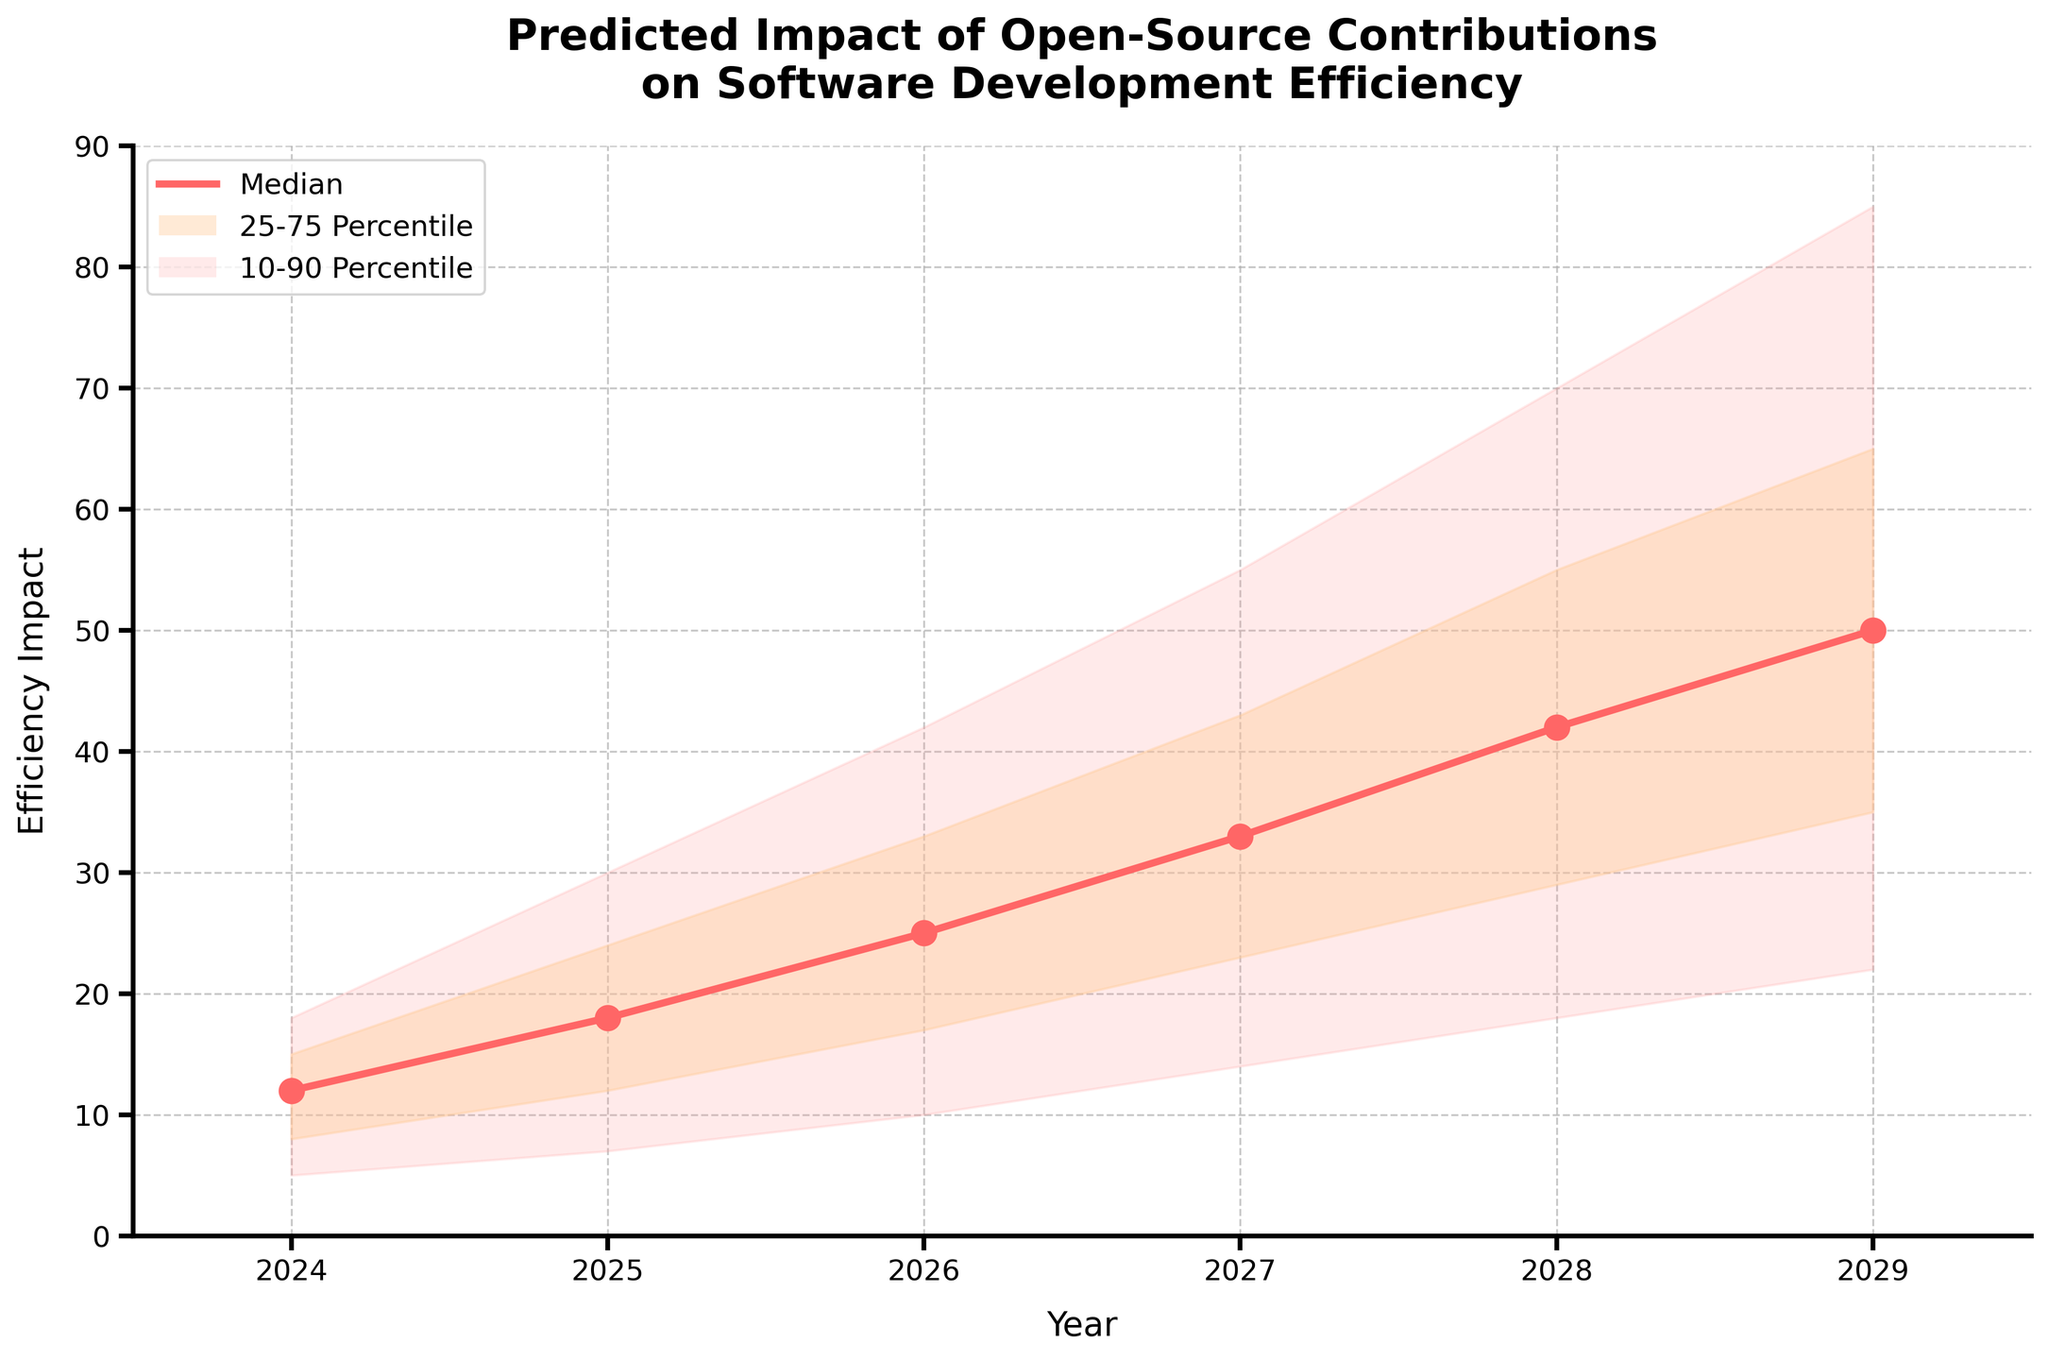what is the title of the chart? The title is displayed at the top of the figure and reads: "Predicted Impact of Open-Source Contributions on Software Development Efficiency"
Answer: Predicted Impact of Open-Source Contributions on Software Development Efficiency what do the shaded areas represent? The legend explains that the colored rectangular areas represent different percentiles: the lightest shaded area indicates the 10-90 percentile range, while the darker shaded area represents the 25-75 percentile range
Answer: 10-90 percentile range and 25-75 percentile range what is the range of the efficiency impact in the year 2026? Referring to the figure's y-axis values for the year 2026, the efficiency impact ranges from 10 to 42
Answer: 10 to 42 how does the median efficiency impact change from 2024 to 2029? Referring to the line marked 'Median' in the figure from 2024 to 2029, the median efficiency impact increases from 12 to 50
Answer: Increases from 12 to 50 which year has the highest predicted maximum impact on software development efficiency? By observing the 'High' line or the upper edge of the lightest shaded area, the highest predicted maximum impact in the year 2029 is 85
Answer: 2029 what is the median predicted impact in 2027? Referring to the median line (bold line) in 2027, the figure shows the efficiency impact is 33
Answer: 33 what could be inferred about the predicted impact trends over the years? From the year 2024 to 2029, the visualization shows an ascending trend in all percentiles and median values, indicating an overall increase in predicted impact over time.
Answer: An increasing trend compare the efficiency impact ranges between 2025 and 2028. Which year has a wider range? Efficiency impact range in 2025 is from 7 to 30, and in 2028 it is from 18 to 70. The range for 2025 width is 23 (30-7) and for 2028 it is 52 (70-18). Thus, 2028 has a wider range.
Answer: 2028 how many years of data are displayed in the chart? The x-axis of the figure shows data points for the years 2024-2029, which means 6 years of data are displayed.
Answer: 6 what trends can we see in the prediction intervals (shaded regions) as time progresses? The shaded regions (prediction intervals) widen progressively from 2024 to 2029, indicating increasing uncertainty over time.
Answer: Increasing uncertainty over time 